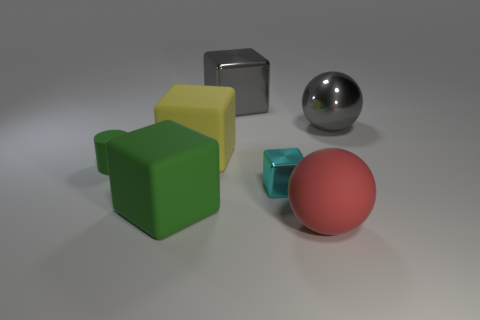Add 1 cyan metal cubes. How many objects exist? 8 Subtract all spheres. How many objects are left? 5 Add 3 rubber blocks. How many rubber blocks exist? 5 Subtract 0 green spheres. How many objects are left? 7 Subtract all big cubes. Subtract all small green cylinders. How many objects are left? 3 Add 3 large yellow cubes. How many large yellow cubes are left? 4 